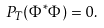<formula> <loc_0><loc_0><loc_500><loc_500>P _ { T } ( \Phi ^ { * } \Phi ) = 0 .</formula> 